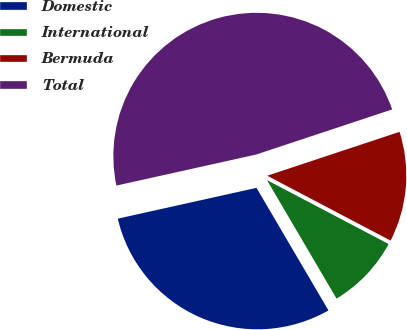Convert chart to OTSL. <chart><loc_0><loc_0><loc_500><loc_500><pie_chart><fcel>Domestic<fcel>International<fcel>Bermuda<fcel>Total<nl><fcel>29.97%<fcel>8.85%<fcel>12.8%<fcel>48.38%<nl></chart> 